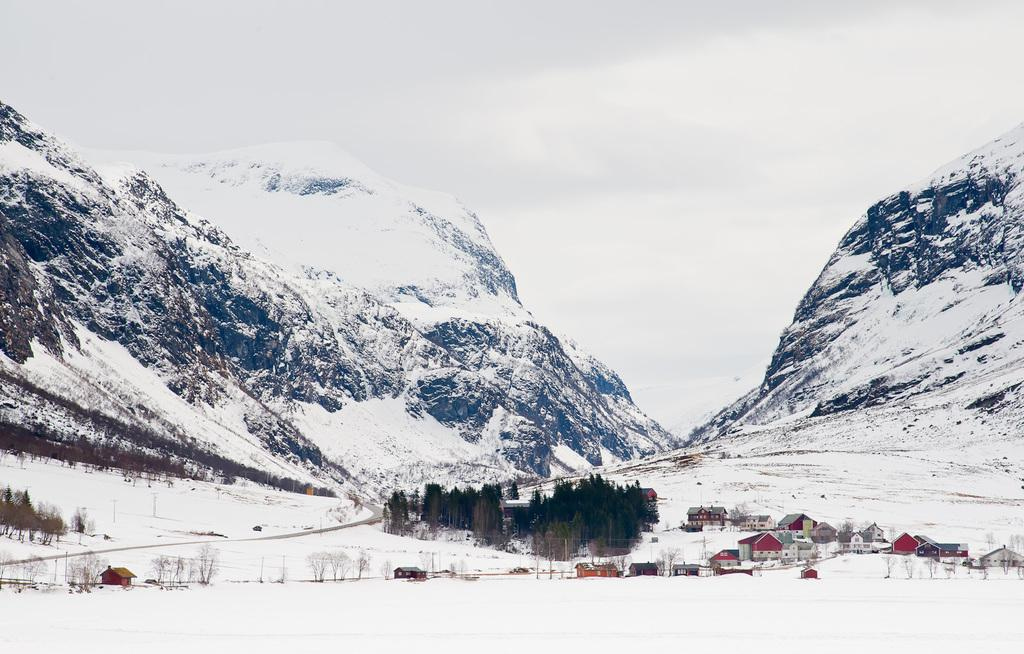What is the terrain like in the image? The mountains in the image are covered in snow. What type of structures can be seen in the image? There are houses visible in the image. What type of vegetation is present in the image? Trees are present in the image. What type of lunch is being served in the image? There is no lunch or any indication of food in the image; it primarily features snow-covered mountains, houses, and trees. 